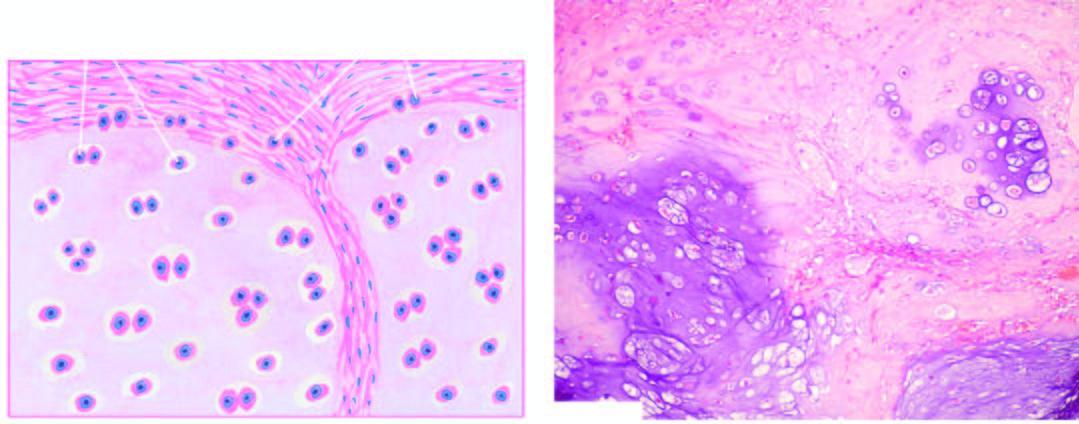what do histologic features include?
Answer the question using a single word or phrase. Invasion of the tumour into adjacent soft tissues and cytologic characteristics of malignancy in the tumour cells 